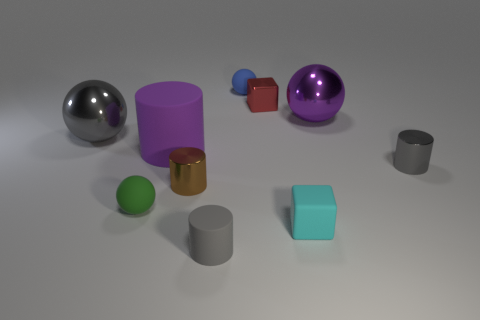The small cylinder that is the same material as the large purple cylinder is what color?
Keep it short and to the point. Gray. Does the purple thing that is to the right of the blue sphere have the same size as the tiny blue ball?
Give a very brief answer. No. What color is the other tiny rubber thing that is the same shape as the small blue object?
Your answer should be very brief. Green. What shape is the purple object that is right of the rubber cylinder that is in front of the cylinder that is to the right of the matte block?
Offer a terse response. Sphere. Does the blue matte object have the same shape as the small brown metal object?
Offer a very short reply. No. What shape is the metallic object that is behind the big metal sphere that is to the right of the small red metal object?
Your response must be concise. Cube. Are there any big spheres?
Give a very brief answer. Yes. What number of small cubes are behind the small cube that is in front of the gray shiny thing that is left of the purple rubber thing?
Give a very brief answer. 1. Does the purple metallic thing have the same shape as the small gray thing that is behind the tiny cyan thing?
Provide a short and direct response. No. Are there more tiny gray metallic objects than tiny metal cylinders?
Keep it short and to the point. No. 